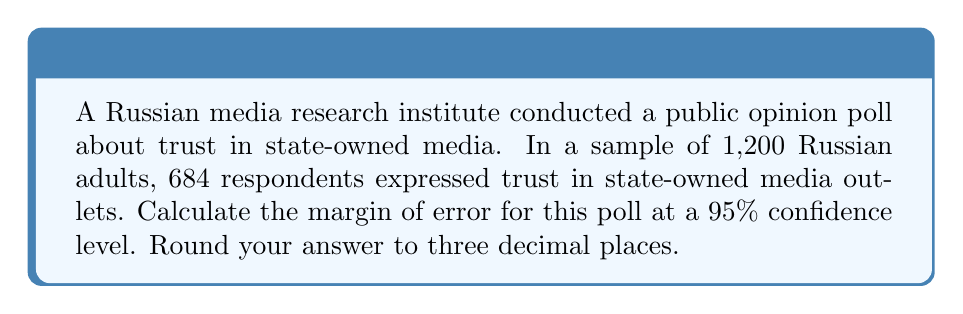Can you solve this math problem? Let's approach this step-by-step:

1) First, we need to calculate the sample proportion:
   $\hat{p} = \frac{684}{1200} = 0.57$

2) The formula for the margin of error (MOE) is:
   $MOE = z * \sqrt{\frac{\hat{p}(1-\hat{p})}{n}}$

   Where:
   - $z$ is the z-score for the desired confidence level
   - $\hat{p}$ is the sample proportion
   - $n$ is the sample size

3) For a 95% confidence level, $z = 1.96$

4) Plugging in the values:
   $MOE = 1.96 * \sqrt{\frac{0.57(1-0.57)}{1200}}$

5) Simplify:
   $MOE = 1.96 * \sqrt{\frac{0.57 * 0.43}{1200}}$
   $MOE = 1.96 * \sqrt{\frac{0.2451}{1200}}$
   $MOE = 1.96 * \sqrt{0.0002043}$
   $MOE = 1.96 * 0.014292$
   $MOE = 0.028012$

6) Rounding to three decimal places:
   $MOE = 0.028$

This means that we can be 95% confident that the true proportion of Russian adults who trust state-owned media is within ±2.8 percentage points of our sample proportion of 57%.
Answer: 0.028 